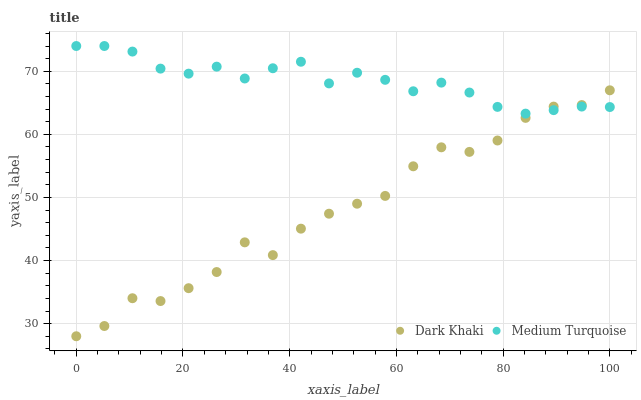Does Dark Khaki have the minimum area under the curve?
Answer yes or no. Yes. Does Medium Turquoise have the maximum area under the curve?
Answer yes or no. Yes. Does Medium Turquoise have the minimum area under the curve?
Answer yes or no. No. Is Medium Turquoise the smoothest?
Answer yes or no. Yes. Is Dark Khaki the roughest?
Answer yes or no. Yes. Is Medium Turquoise the roughest?
Answer yes or no. No. Does Dark Khaki have the lowest value?
Answer yes or no. Yes. Does Medium Turquoise have the lowest value?
Answer yes or no. No. Does Medium Turquoise have the highest value?
Answer yes or no. Yes. Does Dark Khaki intersect Medium Turquoise?
Answer yes or no. Yes. Is Dark Khaki less than Medium Turquoise?
Answer yes or no. No. Is Dark Khaki greater than Medium Turquoise?
Answer yes or no. No. 